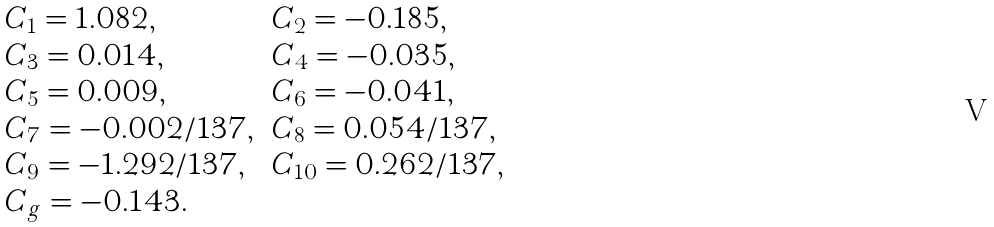<formula> <loc_0><loc_0><loc_500><loc_500>\begin{array} { l l } C _ { 1 } = 1 . 0 8 2 , & C _ { 2 } = - 0 . 1 8 5 , \\ C _ { 3 } = 0 . 0 1 4 , & C _ { 4 } = - 0 . 0 3 5 , \\ C _ { 5 } = 0 . 0 0 9 , & C _ { 6 } = - 0 . 0 4 1 , \\ C _ { 7 } = - 0 . 0 0 2 / 1 3 7 , & C _ { 8 } = 0 . 0 5 4 / 1 3 7 , \\ C _ { 9 } = - 1 . 2 9 2 / 1 3 7 , & C _ { 1 0 } = 0 . 2 6 2 / 1 3 7 , \\ C _ { g } = - 0 . 1 4 3 . & \end{array}</formula> 